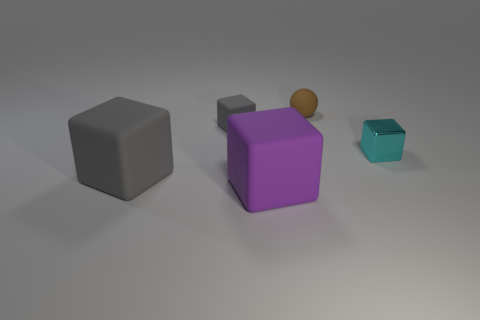There is a cube that is the same size as the metal thing; what material is it?
Keep it short and to the point. Rubber. The large purple rubber object is what shape?
Ensure brevity in your answer.  Cube. How many cyan things are small metallic objects or matte objects?
Offer a very short reply. 1. There is a sphere that is made of the same material as the large gray cube; what size is it?
Keep it short and to the point. Small. Does the tiny object right of the brown rubber object have the same material as the large block to the right of the large gray matte object?
Your answer should be very brief. No. What number of blocks are either big gray things or matte things?
Offer a terse response. 3. There is a gray thing behind the small cube that is right of the rubber ball; how many blocks are to the left of it?
Provide a succinct answer. 1. What material is the other big object that is the same shape as the big gray object?
Offer a very short reply. Rubber. Is there anything else that is made of the same material as the purple object?
Offer a very short reply. Yes. There is a tiny cube to the left of the cyan thing; what color is it?
Provide a short and direct response. Gray. 